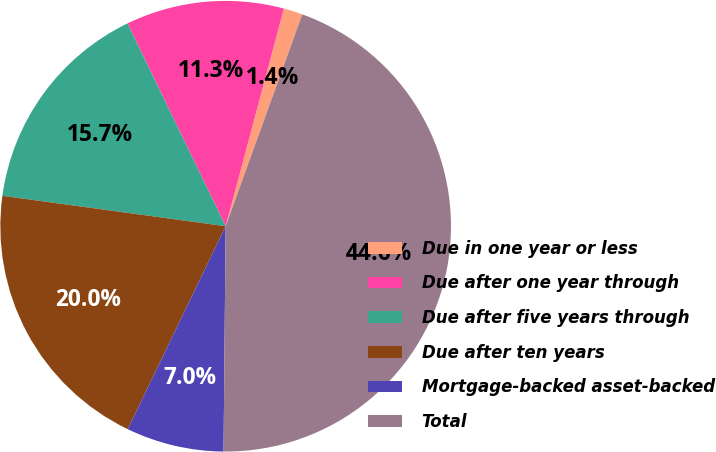<chart> <loc_0><loc_0><loc_500><loc_500><pie_chart><fcel>Due in one year or less<fcel>Due after one year through<fcel>Due after five years through<fcel>Due after ten years<fcel>Mortgage-backed asset-backed<fcel>Total<nl><fcel>1.36%<fcel>11.34%<fcel>15.67%<fcel>20.0%<fcel>7.01%<fcel>44.63%<nl></chart> 